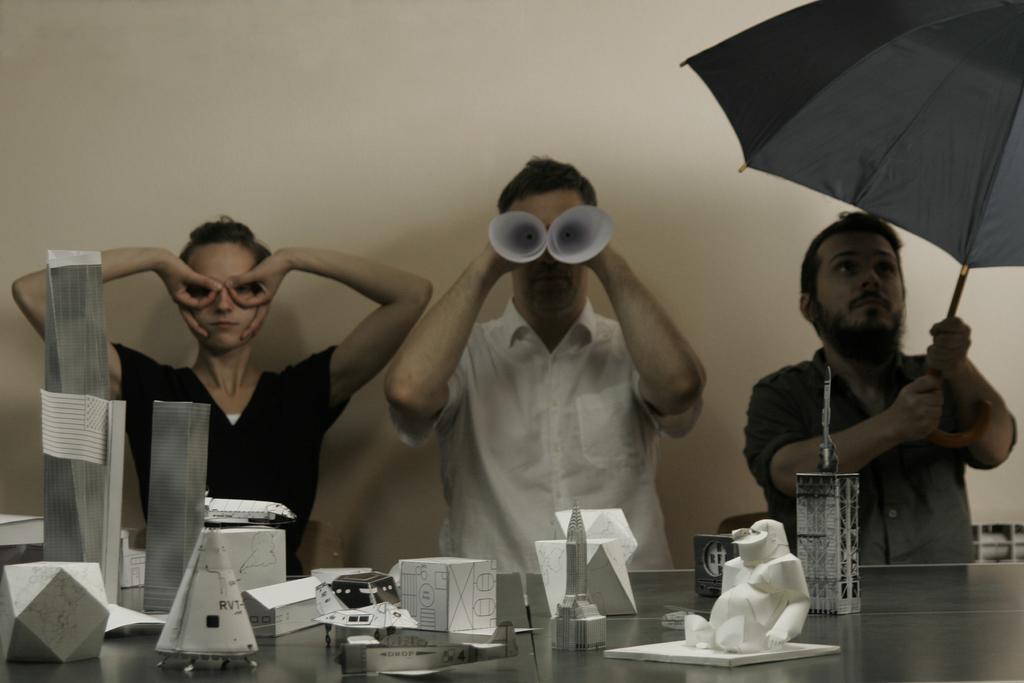How would you summarize this image in a sentence or two? In this picture we can see a woman and two men, a man on the right side is holding an umbrella, a man in the middle is holding papers, there is a table in the front, we can see paper crafts on the table, in the background there is a wall. 